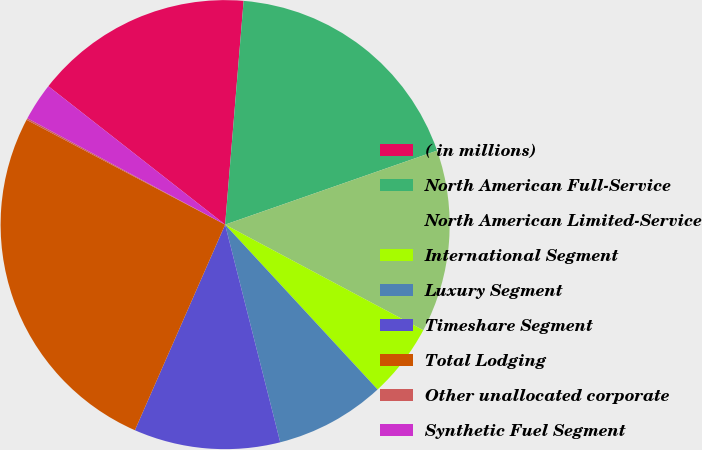Convert chart to OTSL. <chart><loc_0><loc_0><loc_500><loc_500><pie_chart><fcel>( in millions)<fcel>North American Full-Service<fcel>North American Limited-Service<fcel>International Segment<fcel>Luxury Segment<fcel>Timeshare Segment<fcel>Total Lodging<fcel>Other unallocated corporate<fcel>Synthetic Fuel Segment<nl><fcel>15.74%<fcel>18.34%<fcel>13.14%<fcel>5.33%<fcel>7.93%<fcel>10.53%<fcel>26.15%<fcel>0.12%<fcel>2.72%<nl></chart> 